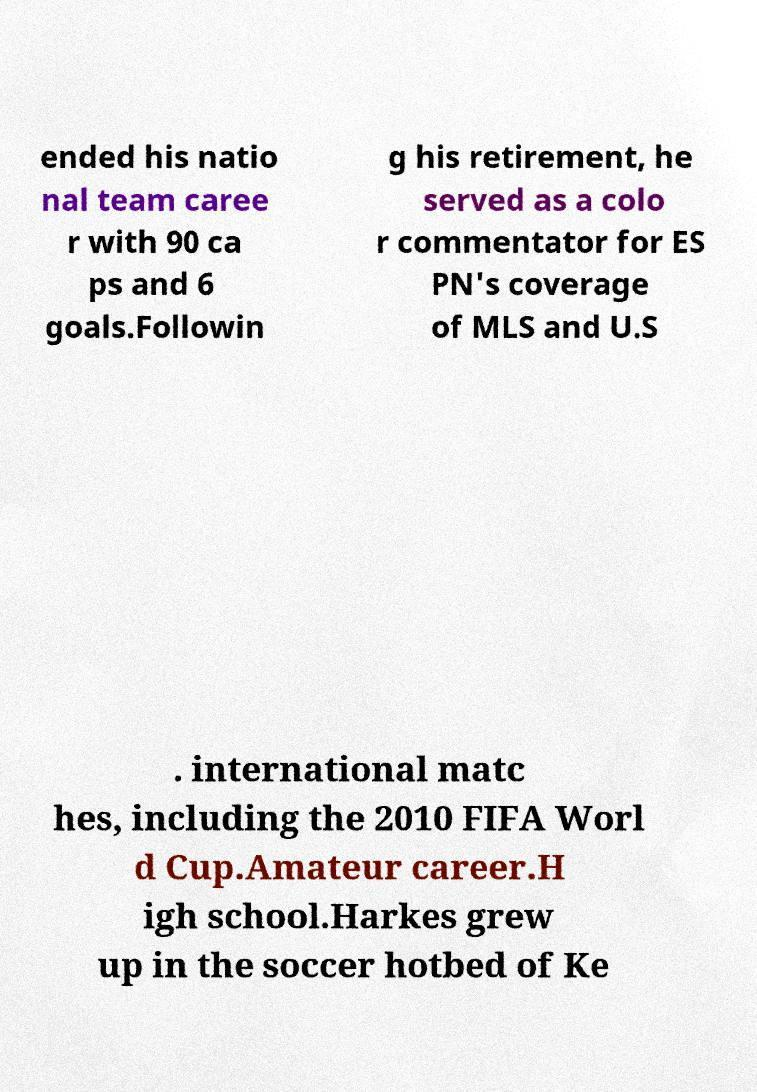Please identify and transcribe the text found in this image. ended his natio nal team caree r with 90 ca ps and 6 goals.Followin g his retirement, he served as a colo r commentator for ES PN's coverage of MLS and U.S . international matc hes, including the 2010 FIFA Worl d Cup.Amateur career.H igh school.Harkes grew up in the soccer hotbed of Ke 